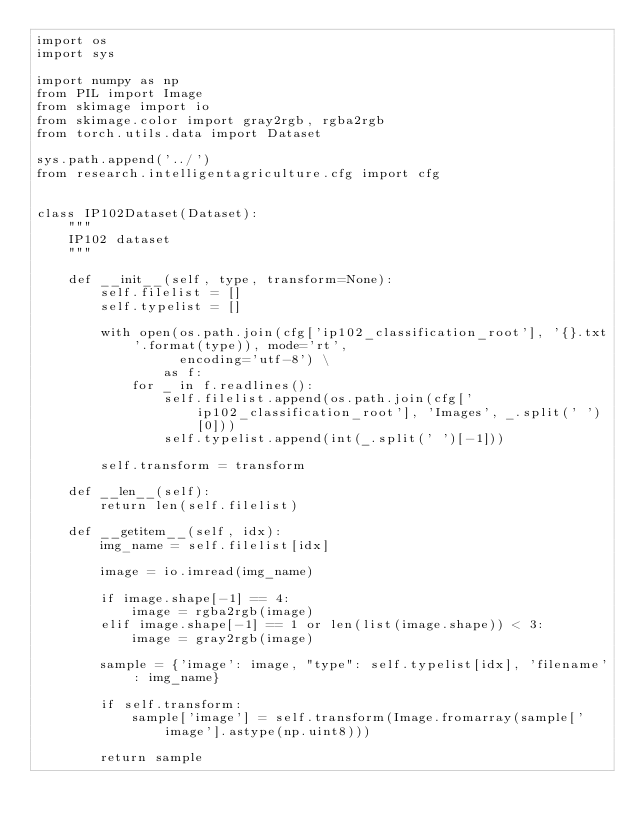Convert code to text. <code><loc_0><loc_0><loc_500><loc_500><_Python_>import os
import sys

import numpy as np
from PIL import Image
from skimage import io
from skimage.color import gray2rgb, rgba2rgb
from torch.utils.data import Dataset

sys.path.append('../')
from research.intelligentagriculture.cfg import cfg


class IP102Dataset(Dataset):
    """
    IP102 dataset
    """

    def __init__(self, type, transform=None):
        self.filelist = []
        self.typelist = []

        with open(os.path.join(cfg['ip102_classification_root'], '{}.txt'.format(type)), mode='rt',
                  encoding='utf-8') \
                as f:
            for _ in f.readlines():
                self.filelist.append(os.path.join(cfg['ip102_classification_root'], 'Images', _.split(' ')[0]))
                self.typelist.append(int(_.split(' ')[-1]))

        self.transform = transform

    def __len__(self):
        return len(self.filelist)

    def __getitem__(self, idx):
        img_name = self.filelist[idx]

        image = io.imread(img_name)

        if image.shape[-1] == 4:
            image = rgba2rgb(image)
        elif image.shape[-1] == 1 or len(list(image.shape)) < 3:
            image = gray2rgb(image)

        sample = {'image': image, "type": self.typelist[idx], 'filename': img_name}

        if self.transform:
            sample['image'] = self.transform(Image.fromarray(sample['image'].astype(np.uint8)))

        return sample
</code> 